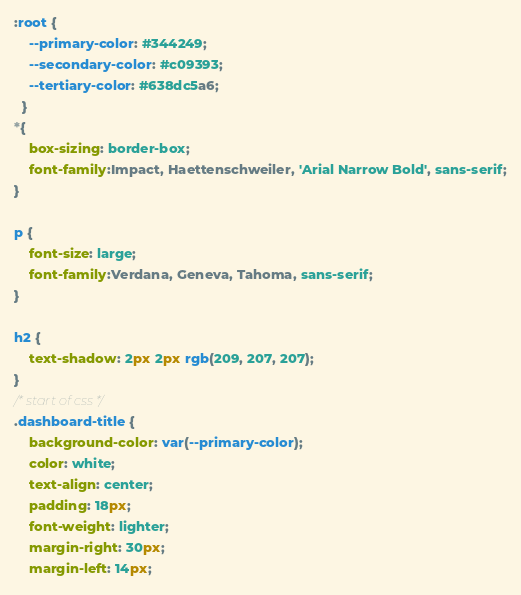<code> <loc_0><loc_0><loc_500><loc_500><_CSS_>:root {
    --primary-color: #344249;
    --secondary-color: #c09393;
    --tertiary-color: #638dc5a6;
  }
*{
    box-sizing: border-box;
    font-family:Impact, Haettenschweiler, 'Arial Narrow Bold', sans-serif;
}

p {
    font-size: large;
    font-family:Verdana, Geneva, Tahoma, sans-serif;
}

h2 {
    text-shadow: 2px 2px rgb(209, 207, 207);
}
/* start of css */
.dashboard-title {
    background-color: var(--primary-color);
    color: white;
    text-align: center;
    padding: 18px;
    font-weight: lighter;
    margin-right: 30px;
    margin-left: 14px;
</code> 